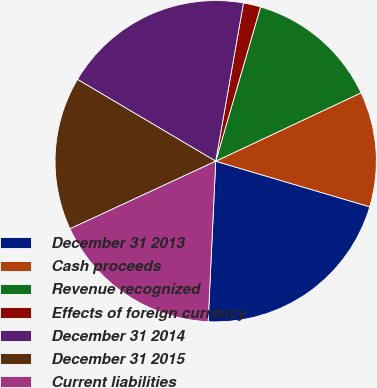Convert chart to OTSL. <chart><loc_0><loc_0><loc_500><loc_500><pie_chart><fcel>December 31 2013<fcel>Cash proceeds<fcel>Revenue recognized<fcel>Effects of foreign currency<fcel>December 31 2014<fcel>December 31 2015<fcel>Current liabilities<nl><fcel>21.17%<fcel>11.58%<fcel>13.5%<fcel>1.74%<fcel>19.26%<fcel>15.42%<fcel>17.34%<nl></chart> 